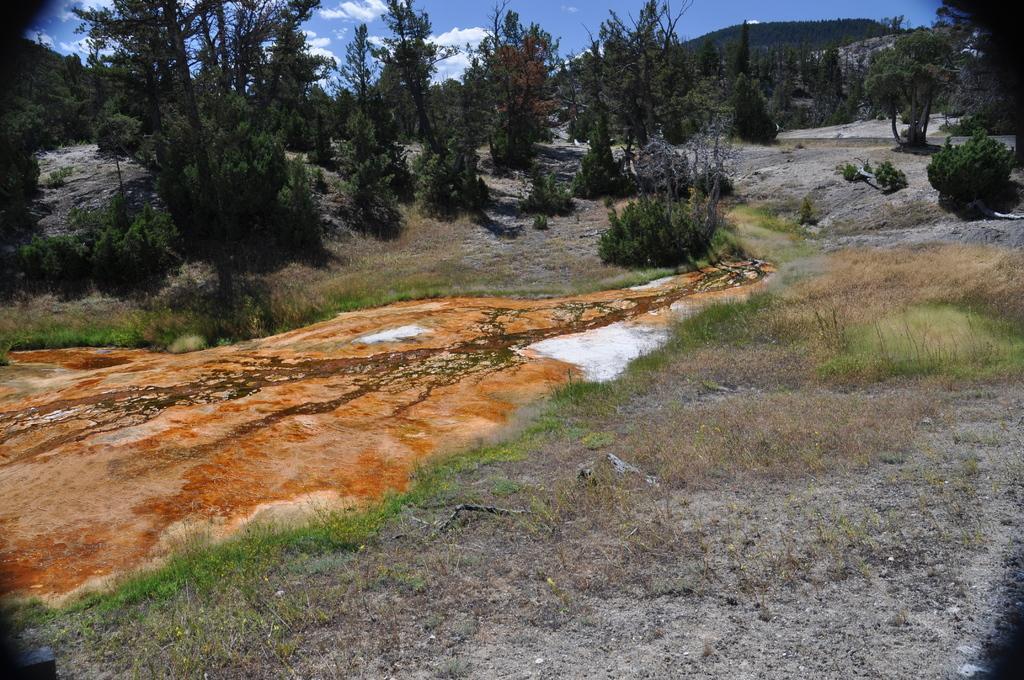Please provide a concise description of this image. In this image there are trees and grass on the ground. In the center there is the red soil. In the background there are mountains. At the top there is the sky. 